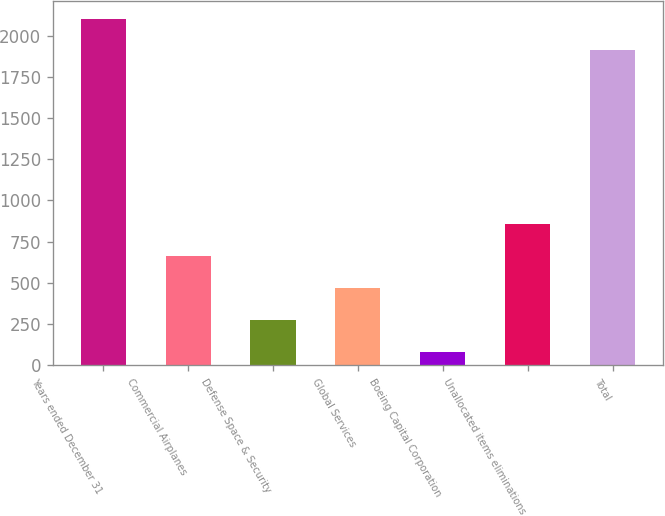Convert chart. <chart><loc_0><loc_0><loc_500><loc_500><bar_chart><fcel>Years ended December 31<fcel>Commercial Airplanes<fcel>Defense Space & Security<fcel>Global Services<fcel>Boeing Capital Corporation<fcel>Unallocated items eliminations<fcel>Total<nl><fcel>2103.3<fcel>662.9<fcel>276.3<fcel>469.6<fcel>83<fcel>856.2<fcel>1910<nl></chart> 